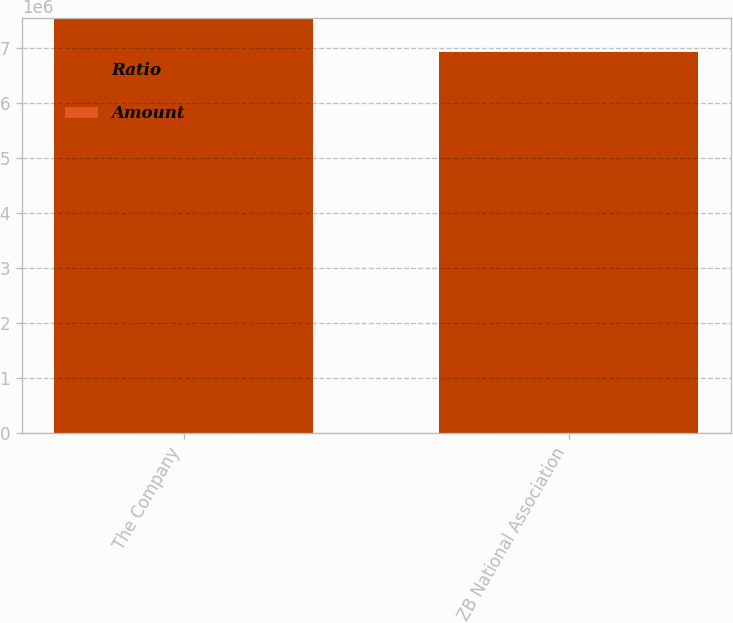Convert chart to OTSL. <chart><loc_0><loc_0><loc_500><loc_500><stacked_bar_chart><ecel><fcel>The Company<fcel>ZB National Association<nl><fcel>Ratio<fcel>7.53576e+06<fcel>6.91831e+06<nl><fcel>Amount<fcel>16.12<fcel>14.84<nl></chart> 